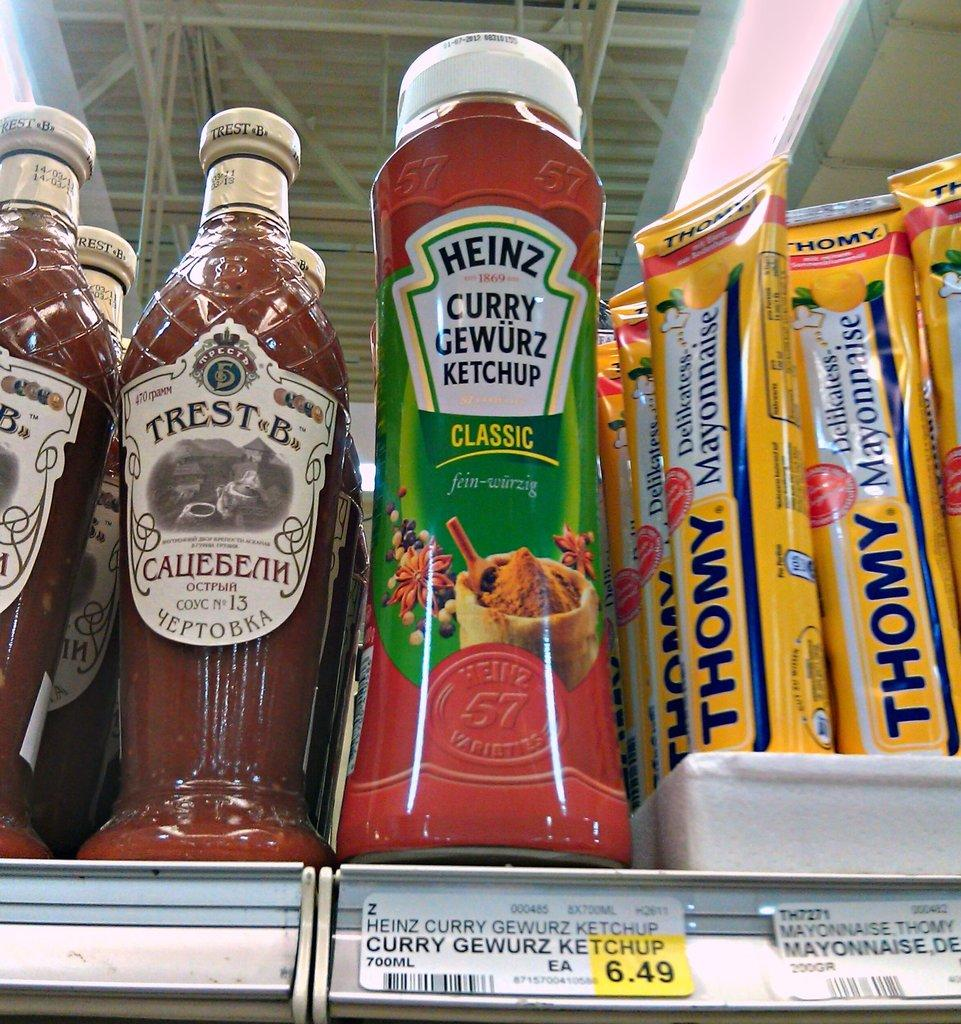<image>
Describe the image concisely. Heinz curry Gewurz Ketchup classic and Trest B Yeptobka sauce. 